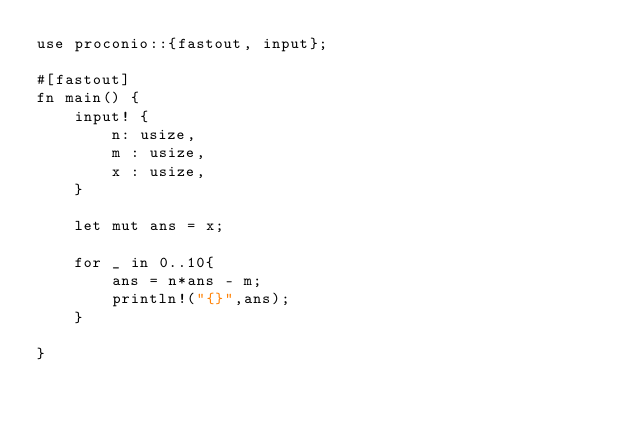Convert code to text. <code><loc_0><loc_0><loc_500><loc_500><_Rust_>use proconio::{fastout, input};

#[fastout]
fn main() {
    input! {
        n: usize,
        m : usize,
        x : usize,
    }

    let mut ans = x;

    for _ in 0..10{
        ans = n*ans - m;
        println!("{}",ans);
    }
    
}
</code> 